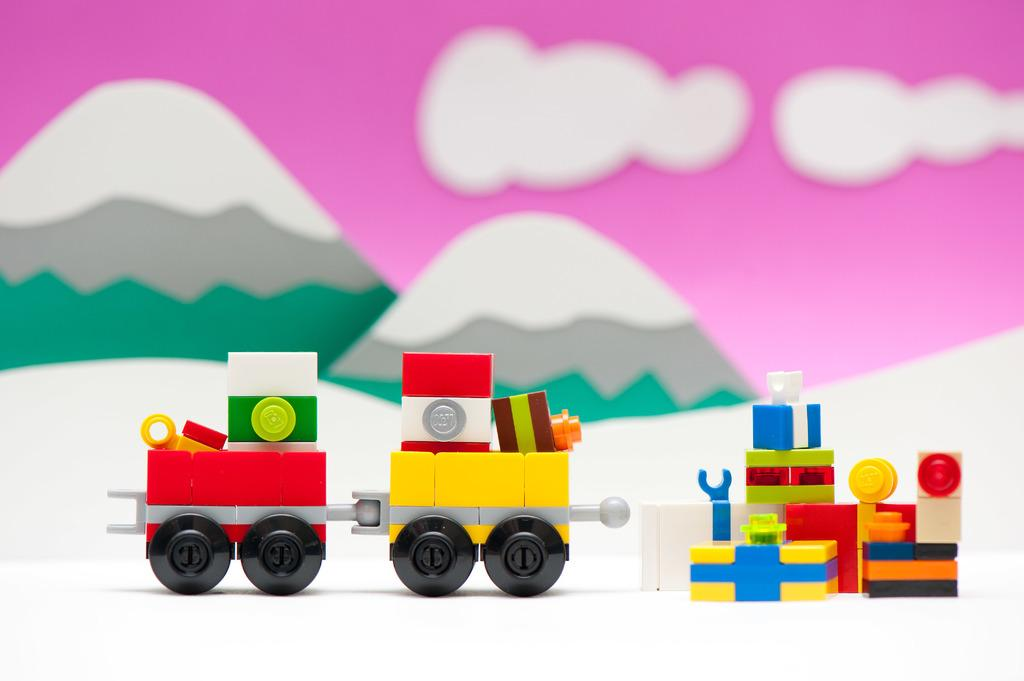What is the main subject of the image? The main subject of the image is a small train. What material is the train made of? The train is made up of Lego toys. What can be seen in the background of the image? There are mountains in the background of the image. What material are the mountains made of? The mountains are made up of cardboard. What type of scarf is draped over the train in the image? There is no scarf present in the image; the train is made up of Lego toys. 